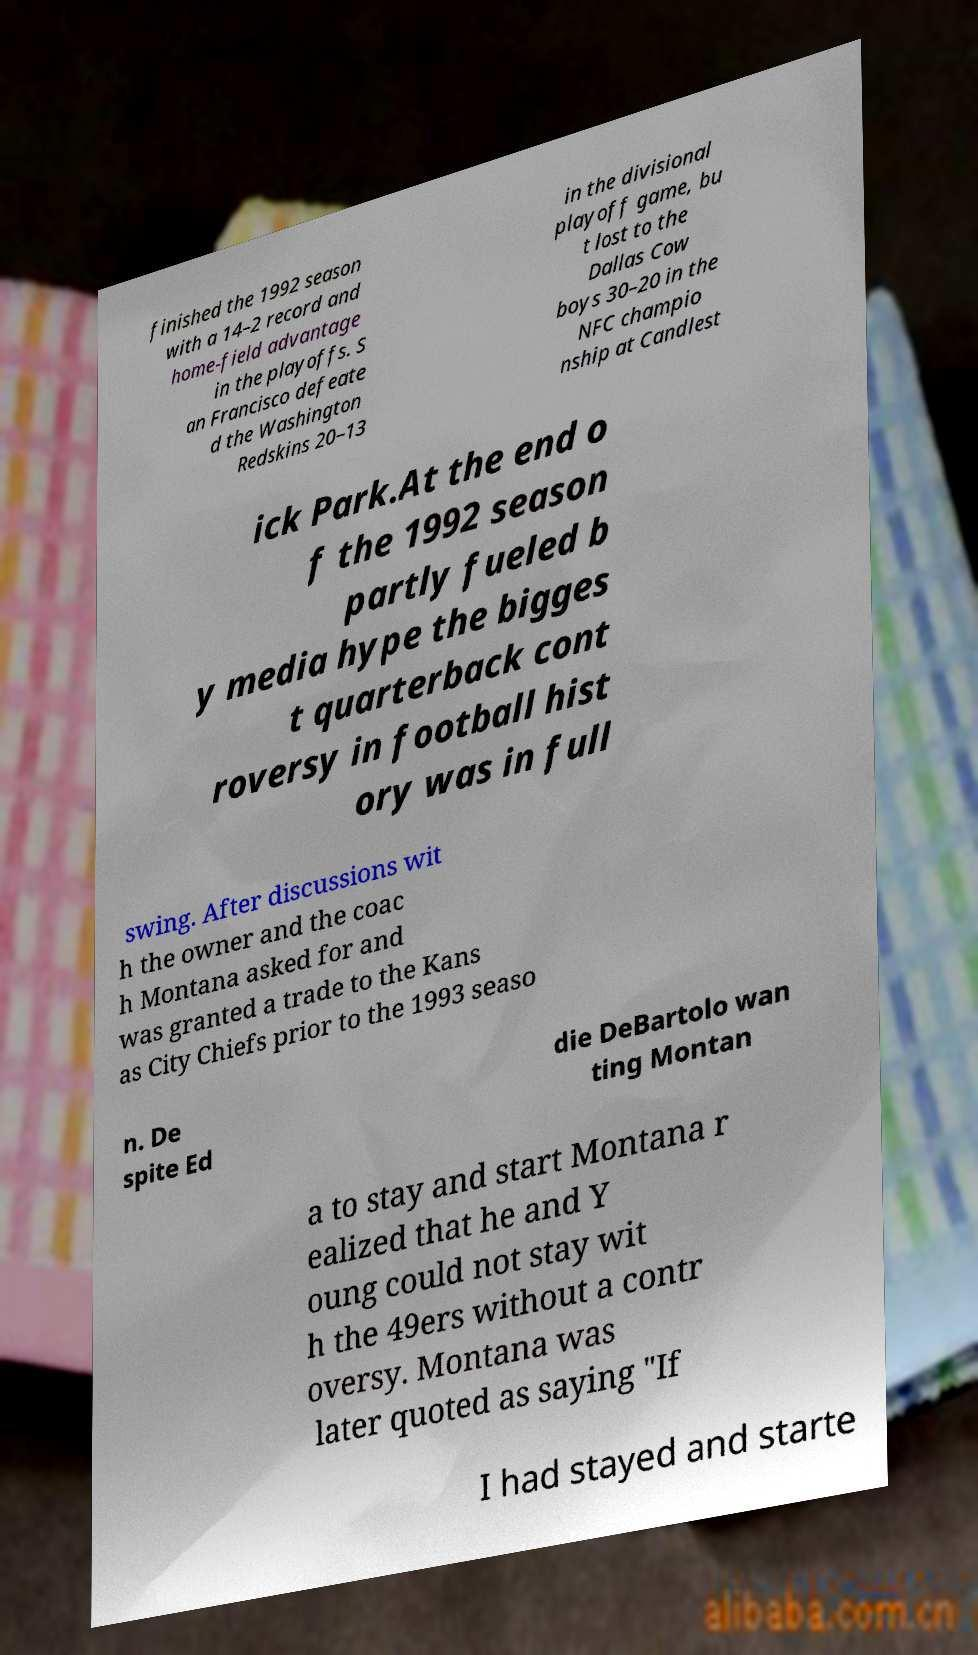Please read and relay the text visible in this image. What does it say? finished the 1992 season with a 14–2 record and home-field advantage in the playoffs. S an Francisco defeate d the Washington Redskins 20–13 in the divisional playoff game, bu t lost to the Dallas Cow boys 30–20 in the NFC champio nship at Candlest ick Park.At the end o f the 1992 season partly fueled b y media hype the bigges t quarterback cont roversy in football hist ory was in full swing. After discussions wit h the owner and the coac h Montana asked for and was granted a trade to the Kans as City Chiefs prior to the 1993 seaso n. De spite Ed die DeBartolo wan ting Montan a to stay and start Montana r ealized that he and Y oung could not stay wit h the 49ers without a contr oversy. Montana was later quoted as saying "If I had stayed and starte 